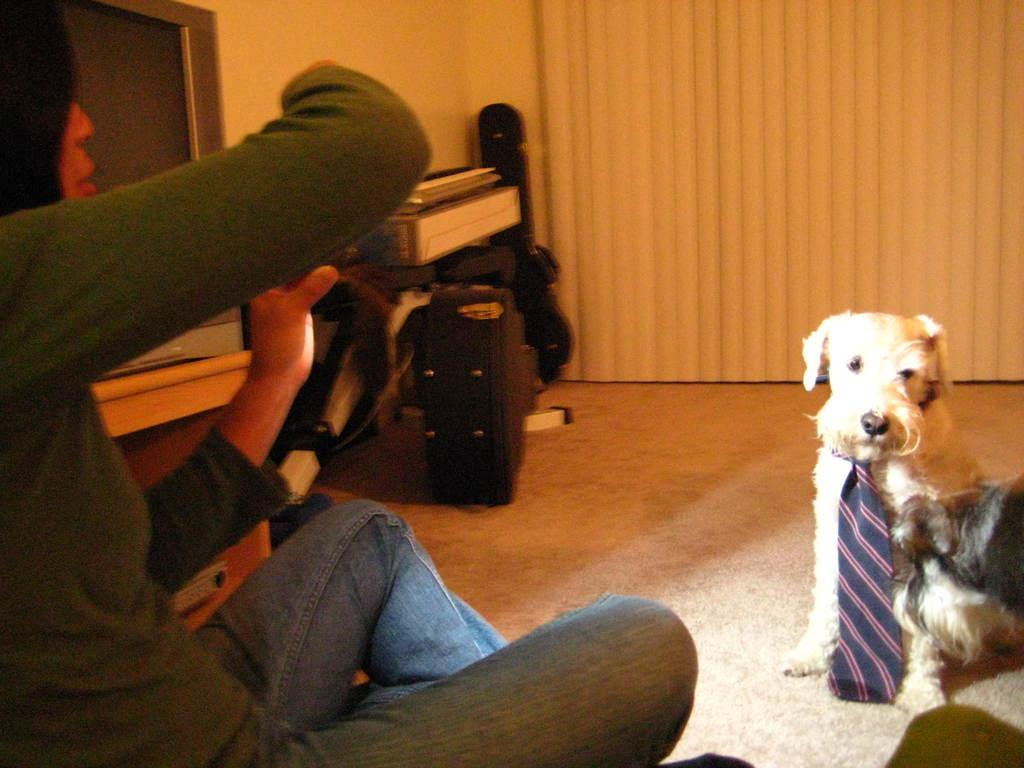What is the woman doing in the image? The woman is sitting on the floor. What is in front of the woman? There is a dog in front of the woman. What is on the table in the image? There is a television on a table. What is on the floor besides the woman? There are bags and other objects on the floor. What can be seen in the background of the image? There is a wall in the image. What causes the thunder in the image? There is no thunder present in the image. What is used to cover the woman and dog in the image? There is no object in the image that is used to cover the woman or dog. 